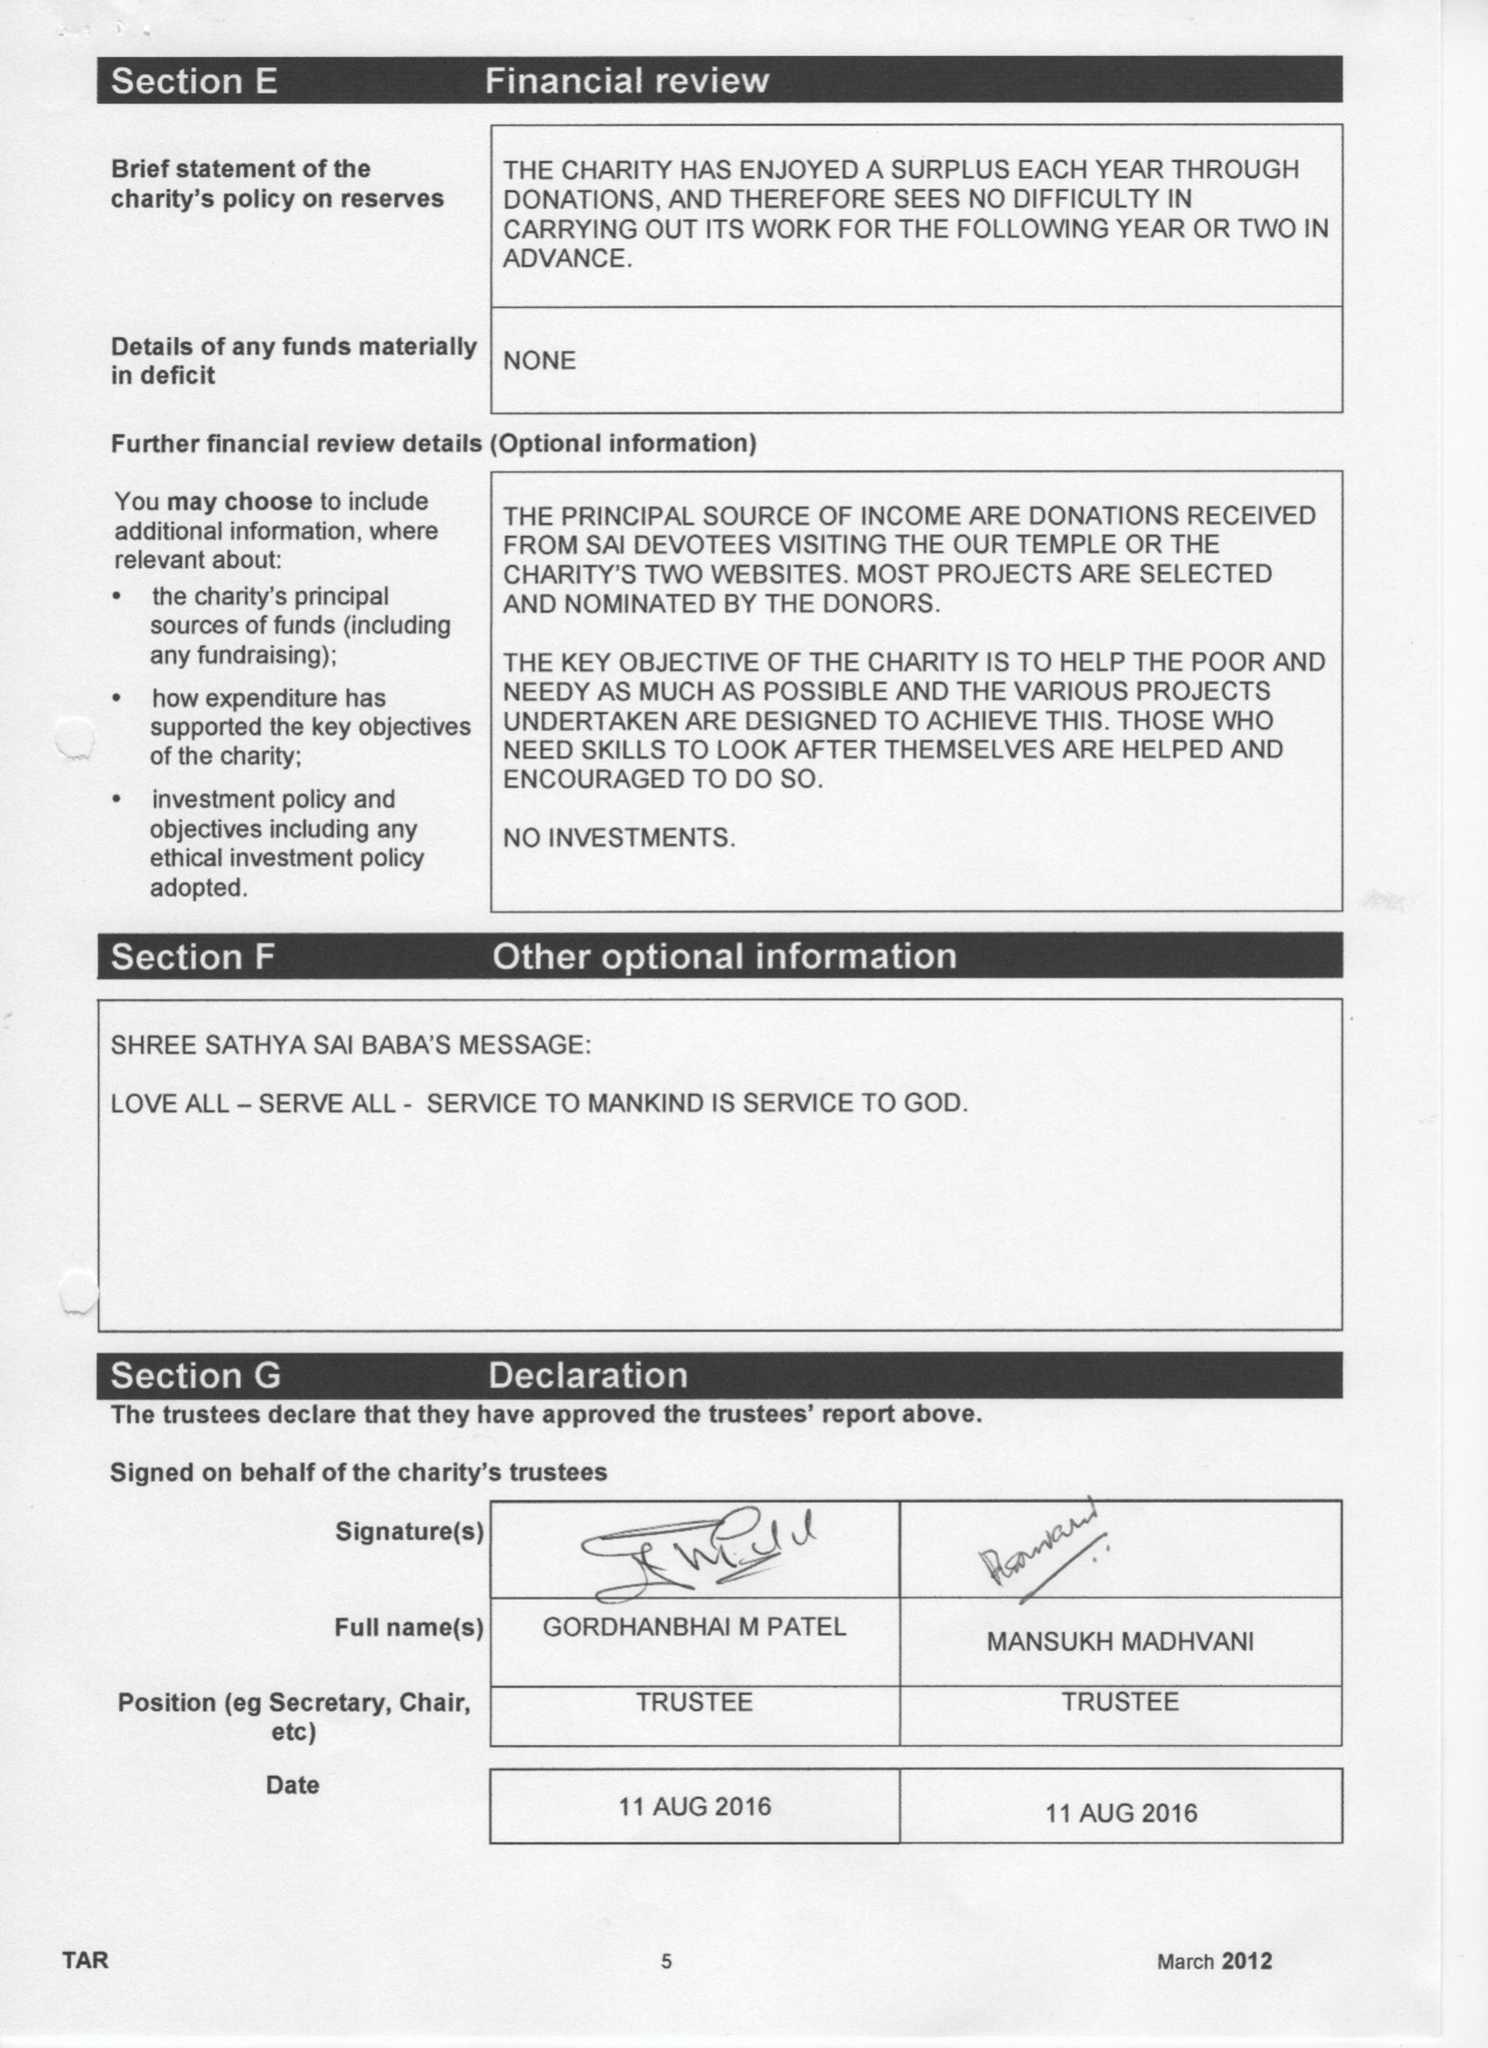What is the value for the spending_annually_in_british_pounds?
Answer the question using a single word or phrase. 64494.00 